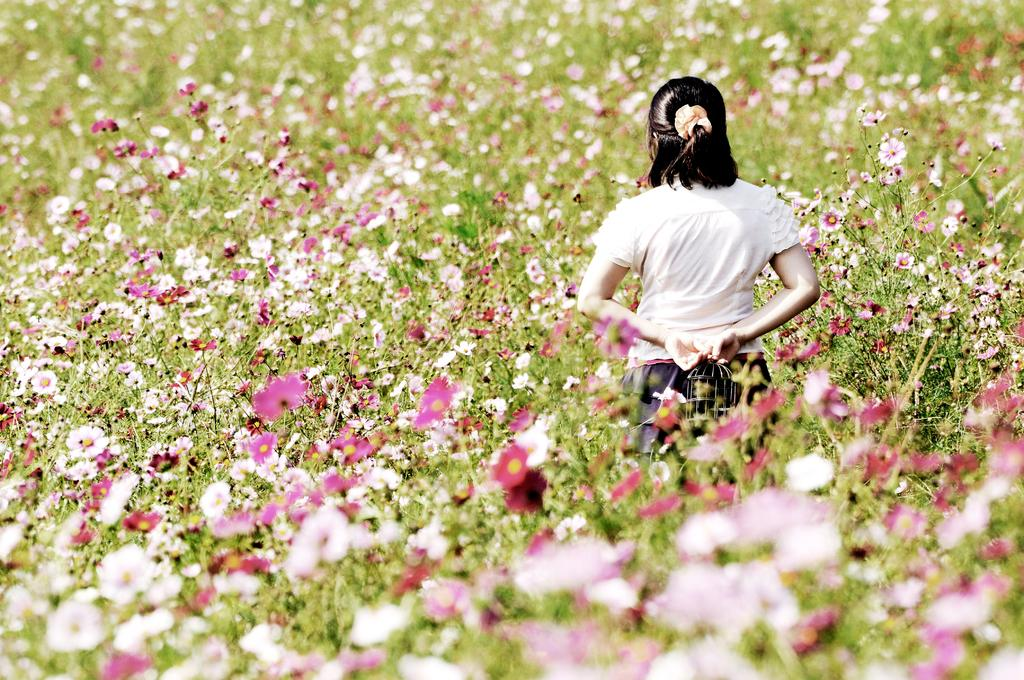Who is present in the image? There is a woman in the image. What is the woman wearing? The woman is wearing a dress. What is the woman's position in the image? The woman is standing on the ground. What can be seen in the background of the image? There are flowers on plants in the background of the image. What type of clam is visible in the woman's hand in the image? There is no clam present in the image; the woman is not holding anything. 